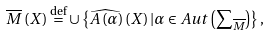<formula> <loc_0><loc_0><loc_500><loc_500>\overline { M } \left ( X \right ) \overset { \text {def} } { = } \cup \left \{ \widehat { A \left ( \alpha \right ) } \left ( X \right ) | \alpha \in A u t \left ( \sum \nolimits _ { \overline { M } } \right ) \right \} ,</formula> 